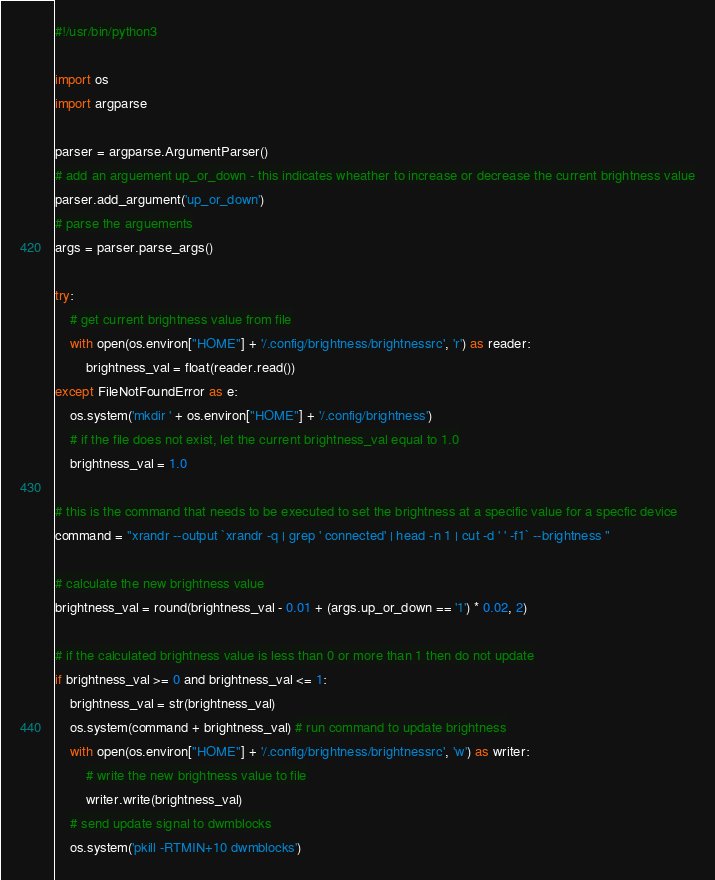Convert code to text. <code><loc_0><loc_0><loc_500><loc_500><_Python_>#!/usr/bin/python3

import os
import argparse

parser = argparse.ArgumentParser()
# add an arguement up_or_down - this indicates wheather to increase or decrease the current brightness value
parser.add_argument('up_or_down')
# parse the arguements
args = parser.parse_args()

try:
    # get current brightness value from file
    with open(os.environ["HOME"] + '/.config/brightness/brightnessrc', 'r') as reader:
        brightness_val = float(reader.read())
except FileNotFoundError as e:
    os.system('mkdir ' + os.environ["HOME"] + '/.config/brightness')
    # if the file does not exist, let the current brightness_val equal to 1.0
    brightness_val = 1.0

# this is the command that needs to be executed to set the brightness at a specific value for a specfic device
command = "xrandr --output `xrandr -q | grep ' connected' | head -n 1 | cut -d ' ' -f1` --brightness "

# calculate the new brightness value
brightness_val = round(brightness_val - 0.01 + (args.up_or_down == '1') * 0.02, 2)

# if the calculated brightness value is less than 0 or more than 1 then do not update
if brightness_val >= 0 and brightness_val <= 1:
    brightness_val = str(brightness_val)
    os.system(command + brightness_val) # run command to update brightness
    with open(os.environ["HOME"] + '/.config/brightness/brightnessrc', 'w') as writer:
        # write the new brightness value to file
        writer.write(brightness_val)
    # send update signal to dwmblocks
    os.system('pkill -RTMIN+10 dwmblocks')
</code> 